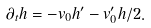Convert formula to latex. <formula><loc_0><loc_0><loc_500><loc_500>\partial _ { t } h = - v _ { 0 } h ^ { \prime } - v ^ { \prime } _ { 0 } h / 2 .</formula> 